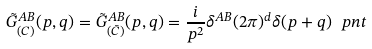Convert formula to latex. <formula><loc_0><loc_0><loc_500><loc_500>\tilde { G } ^ { A B } _ { ( C ) } ( p , q ) = \tilde { G } ^ { A B } _ { ( \bar { C } ) } ( p , q ) = \frac { i } { p ^ { 2 } } \delta ^ { A B } ( 2 \pi ) ^ { d } \delta ( p + q ) \ p n t</formula> 